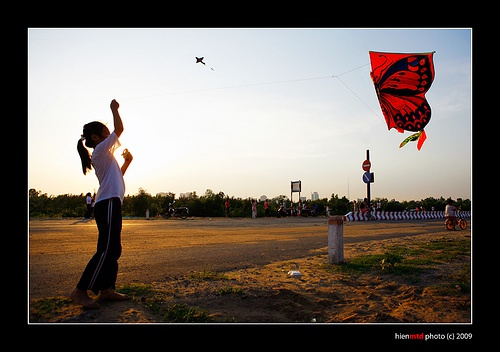Describe the objects in this image and their specific colors. I can see people in black, purple, and maroon tones, kite in black, red, and maroon tones, bicycle in black and maroon tones, people in black, maroon, and gray tones, and people in black, maroon, olive, and brown tones in this image. 